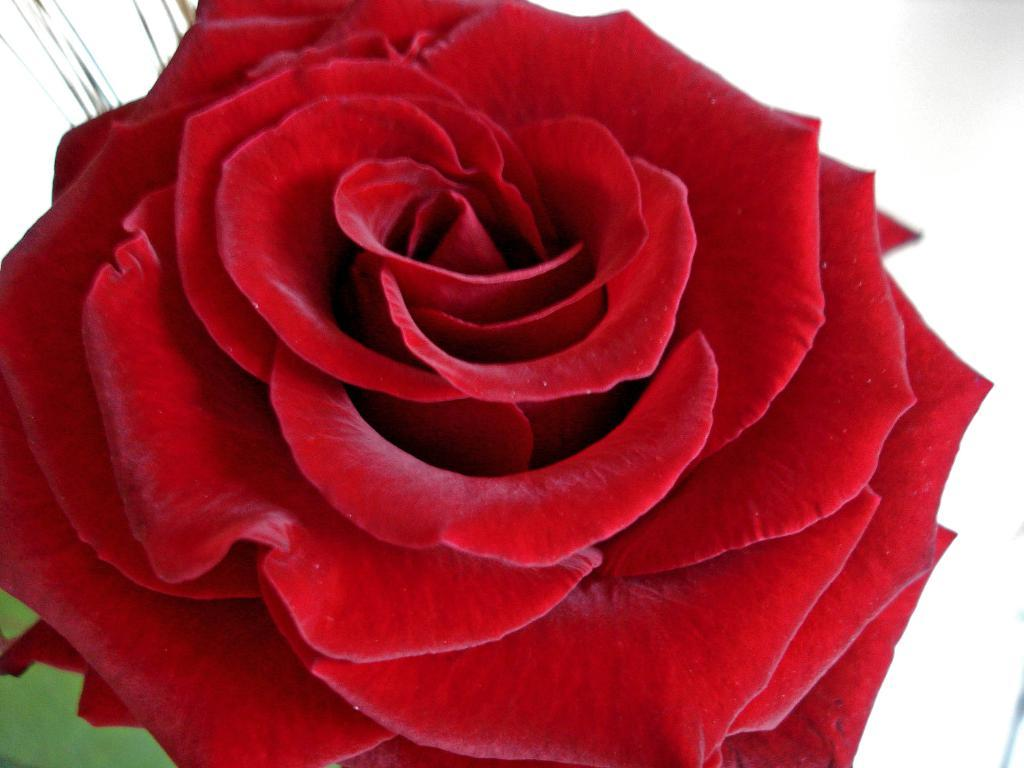What type of flower is in the image? There is a red rose in the image. What color is the background of the image? The background of the image is white. What type of punishment is being handed out in the image? There is no punishment present in the image; it features a red rose against a white background. What idea is being conveyed by the image? The image does not convey a specific idea; it simply shows a red rose against a white background. 